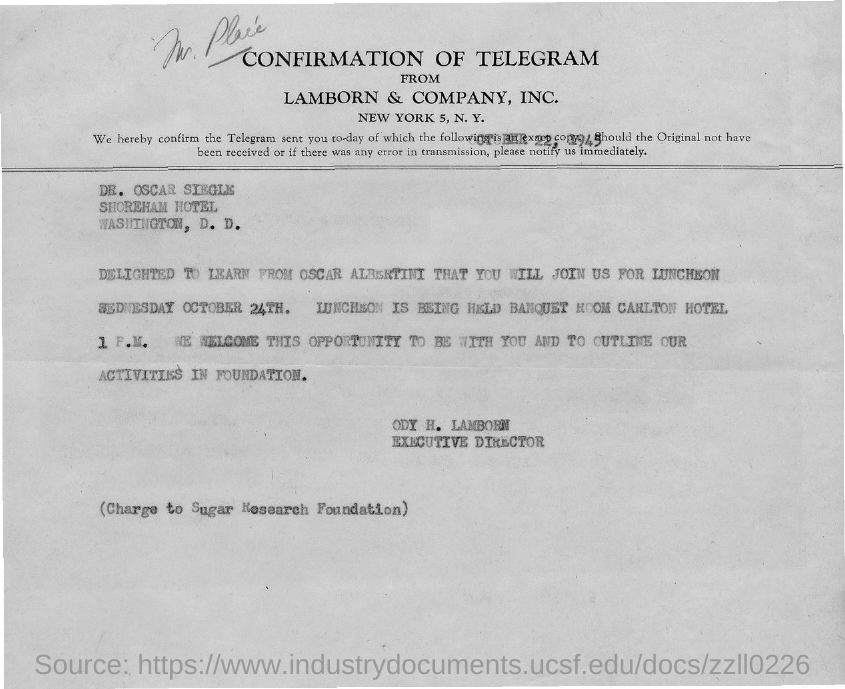Specify some key components in this picture. The confirmation is sent to Dr. Oscar Siegle. The sender of this confirmation is ODY H. LAMBORN. Ody H. Lamborn is the executive director. 